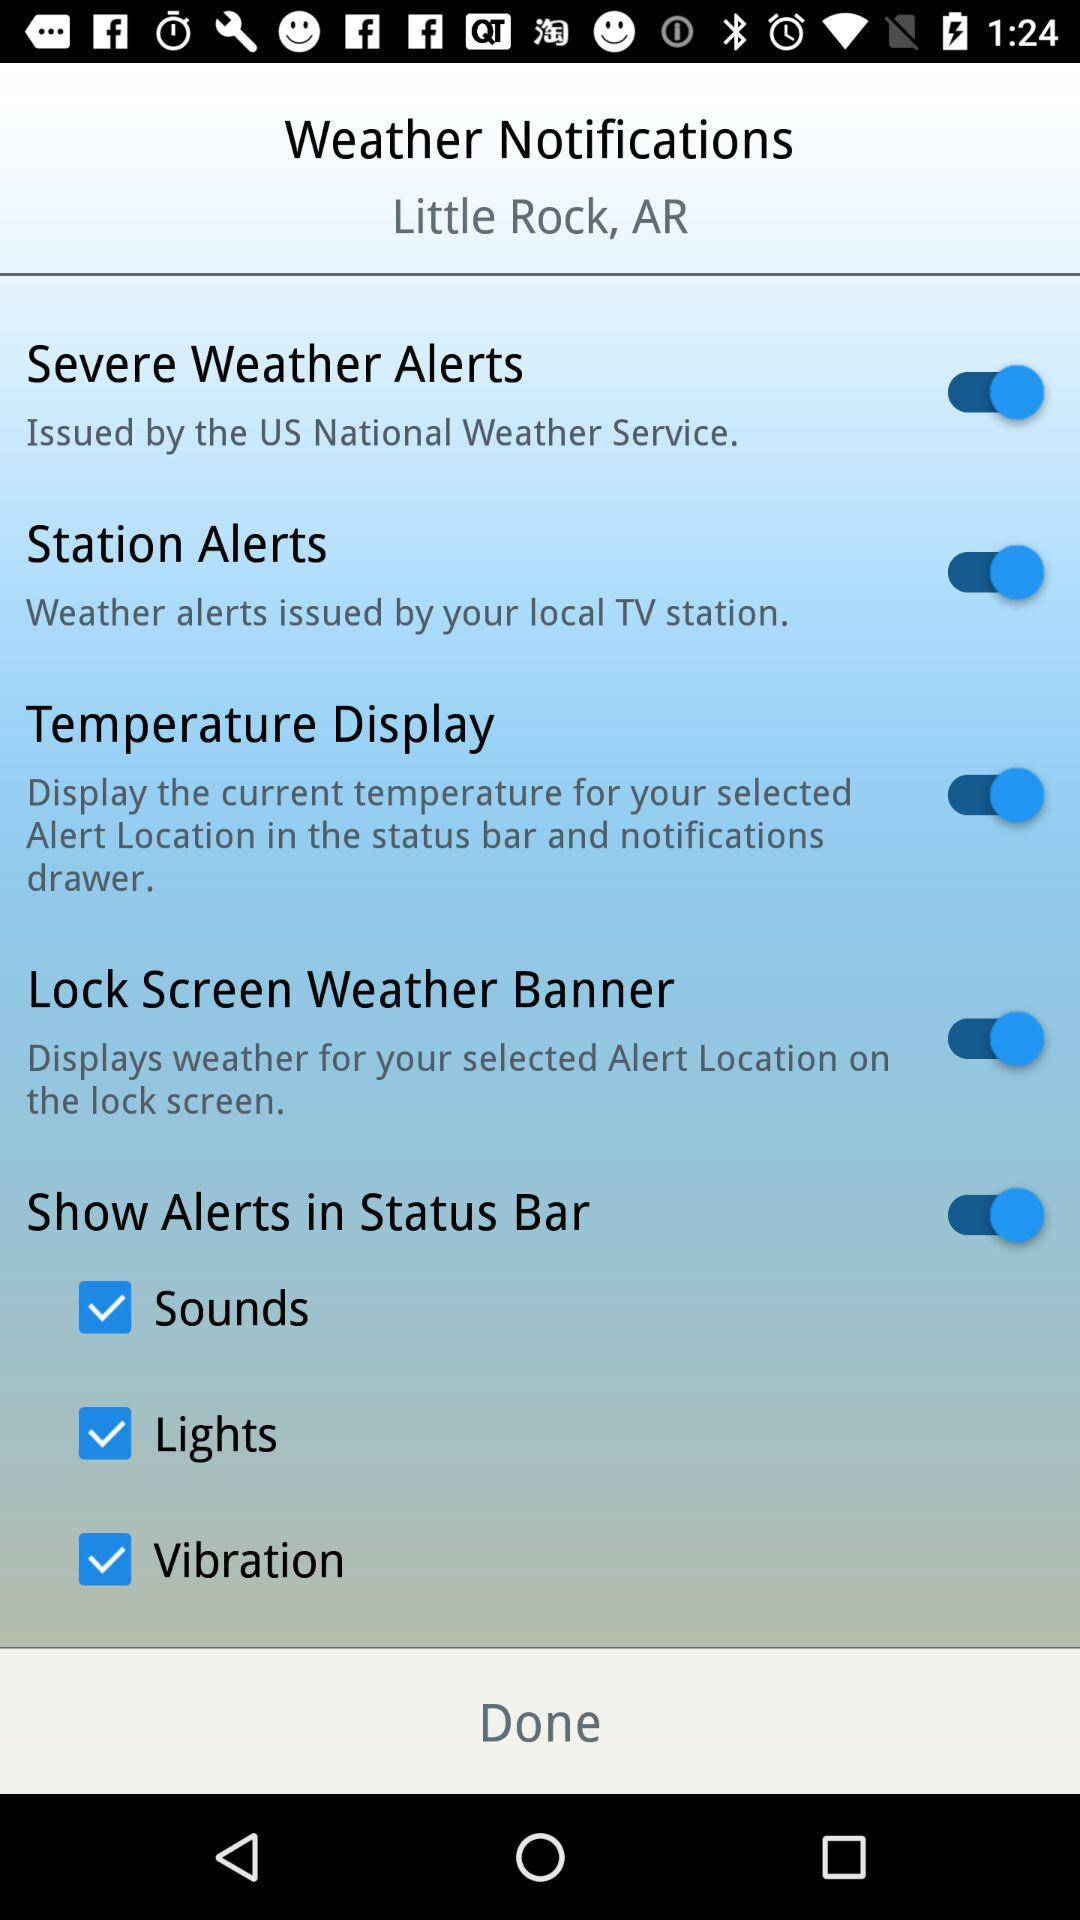How many checkboxes are on this screen?
Answer the question using a single word or phrase. 3 